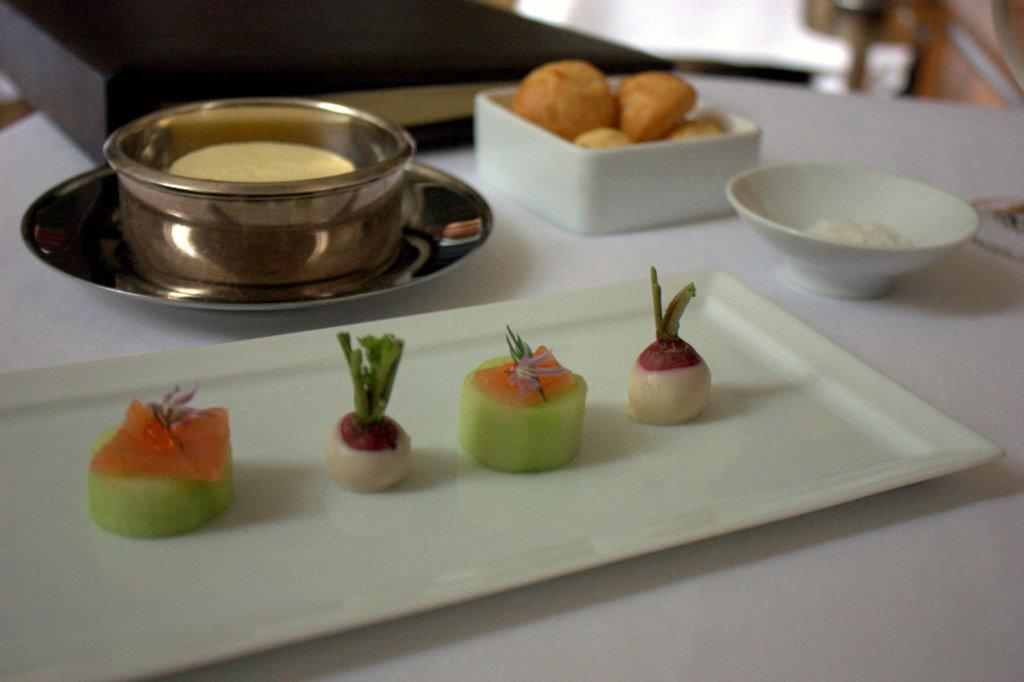What is placed on the white color tray in the image? There are food items on a white color tray in the image. What type of dishware can be seen in the image? There are bowls and a saucer in the image. What other objects are present on the white color table in the image? There are other objects on a white color table in the image, but their specific details are not mentioned in the facts. How would you describe the background of the image? The background of the image is blurred. Can you see any snails crawling on the food items in the image? There are no snails present in the image. What type of mine is depicted in the image? There is no mine present in the image. 